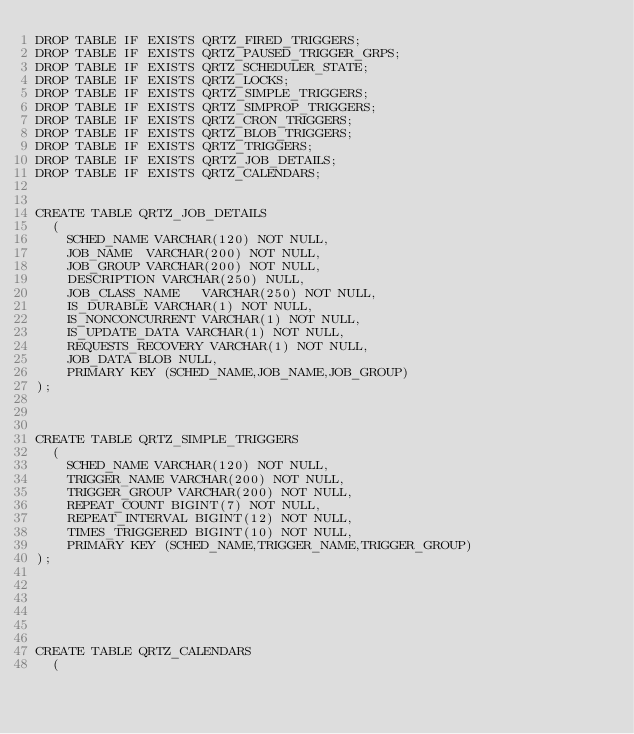<code> <loc_0><loc_0><loc_500><loc_500><_SQL_>DROP TABLE IF EXISTS QRTZ_FIRED_TRIGGERS;
DROP TABLE IF EXISTS QRTZ_PAUSED_TRIGGER_GRPS;
DROP TABLE IF EXISTS QRTZ_SCHEDULER_STATE;
DROP TABLE IF EXISTS QRTZ_LOCKS;
DROP TABLE IF EXISTS QRTZ_SIMPLE_TRIGGERS;
DROP TABLE IF EXISTS QRTZ_SIMPROP_TRIGGERS;
DROP TABLE IF EXISTS QRTZ_CRON_TRIGGERS;
DROP TABLE IF EXISTS QRTZ_BLOB_TRIGGERS;
DROP TABLE IF EXISTS QRTZ_TRIGGERS;
DROP TABLE IF EXISTS QRTZ_JOB_DETAILS;
DROP TABLE IF EXISTS QRTZ_CALENDARS;


CREATE TABLE QRTZ_JOB_DETAILS
  (
    SCHED_NAME VARCHAR(120) NOT NULL,
    JOB_NAME  VARCHAR(200) NOT NULL,
    JOB_GROUP VARCHAR(200) NOT NULL,
    DESCRIPTION VARCHAR(250) NULL,
    JOB_CLASS_NAME   VARCHAR(250) NOT NULL,
    IS_DURABLE VARCHAR(1) NOT NULL,
    IS_NONCONCURRENT VARCHAR(1) NOT NULL,
    IS_UPDATE_DATA VARCHAR(1) NOT NULL,
    REQUESTS_RECOVERY VARCHAR(1) NOT NULL,
    JOB_DATA BLOB NULL,
    PRIMARY KEY (SCHED_NAME,JOB_NAME,JOB_GROUP)
);



CREATE TABLE QRTZ_SIMPLE_TRIGGERS
  (
    SCHED_NAME VARCHAR(120) NOT NULL,
    TRIGGER_NAME VARCHAR(200) NOT NULL,
    TRIGGER_GROUP VARCHAR(200) NOT NULL,
    REPEAT_COUNT BIGINT(7) NOT NULL,
    REPEAT_INTERVAL BIGINT(12) NOT NULL,
    TIMES_TRIGGERED BIGINT(10) NOT NULL,
    PRIMARY KEY (SCHED_NAME,TRIGGER_NAME,TRIGGER_GROUP)
);






CREATE TABLE QRTZ_CALENDARS
  (</code> 